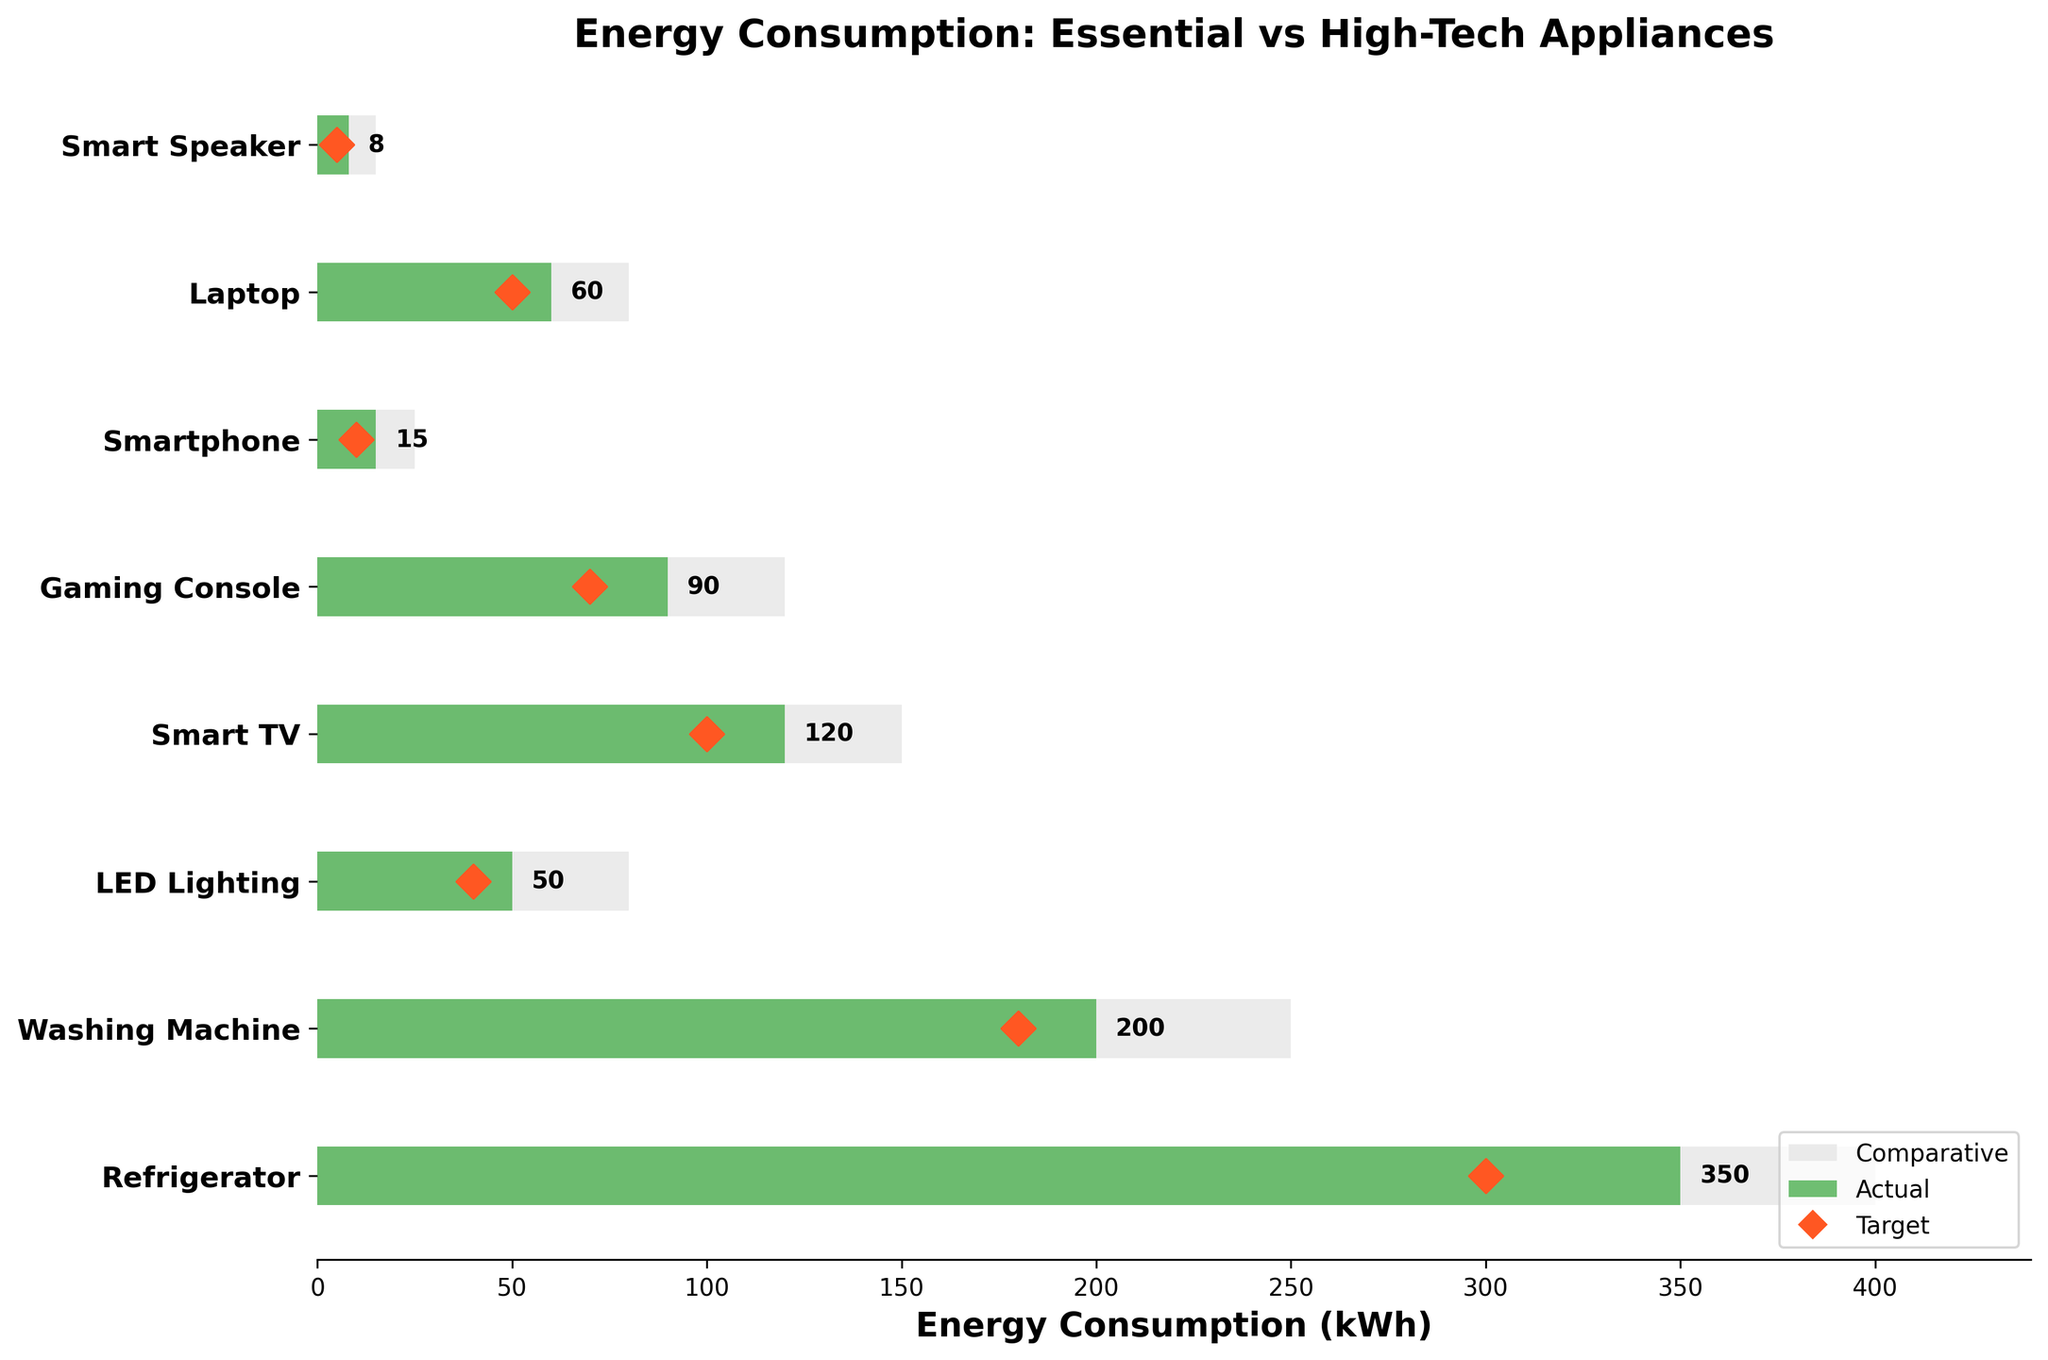What is the color used to represent the 'Actual' energy consumption? The figure uses a green color to represent the 'Actual' energy consumption values. This is visually noticeable as the green bars are distinct from the others.
Answer: Green How many categories of household appliances and gadgets are shown in the figure? By counting the number of horizontal bars along the y-axis, we can see that there are 8 categories, ranging from "Refrigerator" to "Smart Speaker".
Answer: 8 Which appliance has the highest actual energy consumption? By looking at the longest green bar in the figure, we can see that the "Refrigerator" has the highest actual energy consumption of 350 kWh.
Answer: Refrigerator What is the actual energy consumption of the Gaming Console? We locate the green bar corresponding to "Gaming Console" and read the number displayed at the end of the bar which is 90 kWh.
Answer: 90 kWh How does the target energy consumption for the Smart TV compare to its actual consumption? The target energy consumption is shown as a red diamond marker. For "Smart TV", the target is marked at 100 kWh while the green bar shows an actual consumption of 120 kWh. Therefore, the actual consumption exceeds the target by 20 kWh.
Answer: 20 kWh more What is the difference between the comparative and actual energy consumption of the Laptop? The figure shows the comparative and actual consumption bars next to each other. For "Laptop", the comparative consumption is 80 kWh and the actual consumption is 60 kWh. The difference is 80 - 60 = 20 kWh.
Answer: 20 kWh Which category has an actual consumption that is double its target? By comparing the green bars (actual) and red diamond markers (target), we see that the actual consumption of "Smartphone" is 15 kWh and its target is 10 kWh. The actual consumption here is roughly 1.5 times its target, not double. However, for "Smart Speaker", the actual consumption is 8 kWh and the target is 5 kWh, not double either. Therefore, no category exactly fits the criteria.
Answer: None What's the combined actual energy consumption of the Washing Machine and the LED Lighting? By adding the values of the green bars for "Washing Machine" (200 kWh) and "LED Lighting" (50 kWh), we get a total of 200 + 50 = 250 kWh.
Answer: 250 kWh Is there any category where the actual consumption is lower than both the comparative and target values? By observing the green, grey, and red markers, we see that "Smartphone" has an actual consumption of 15 kWh which is higher than the target (10 kWh) but lower than the comparative (25 kWh) value. Another category with such characteristics is "Smart Speaker", where actual consumption (8 kWh) is below its comparative (15 kWh) but higher than its target (5 kWh). Hence, there is no category where the actual consumption is lower than both the comparative and target values.
Answer: None 